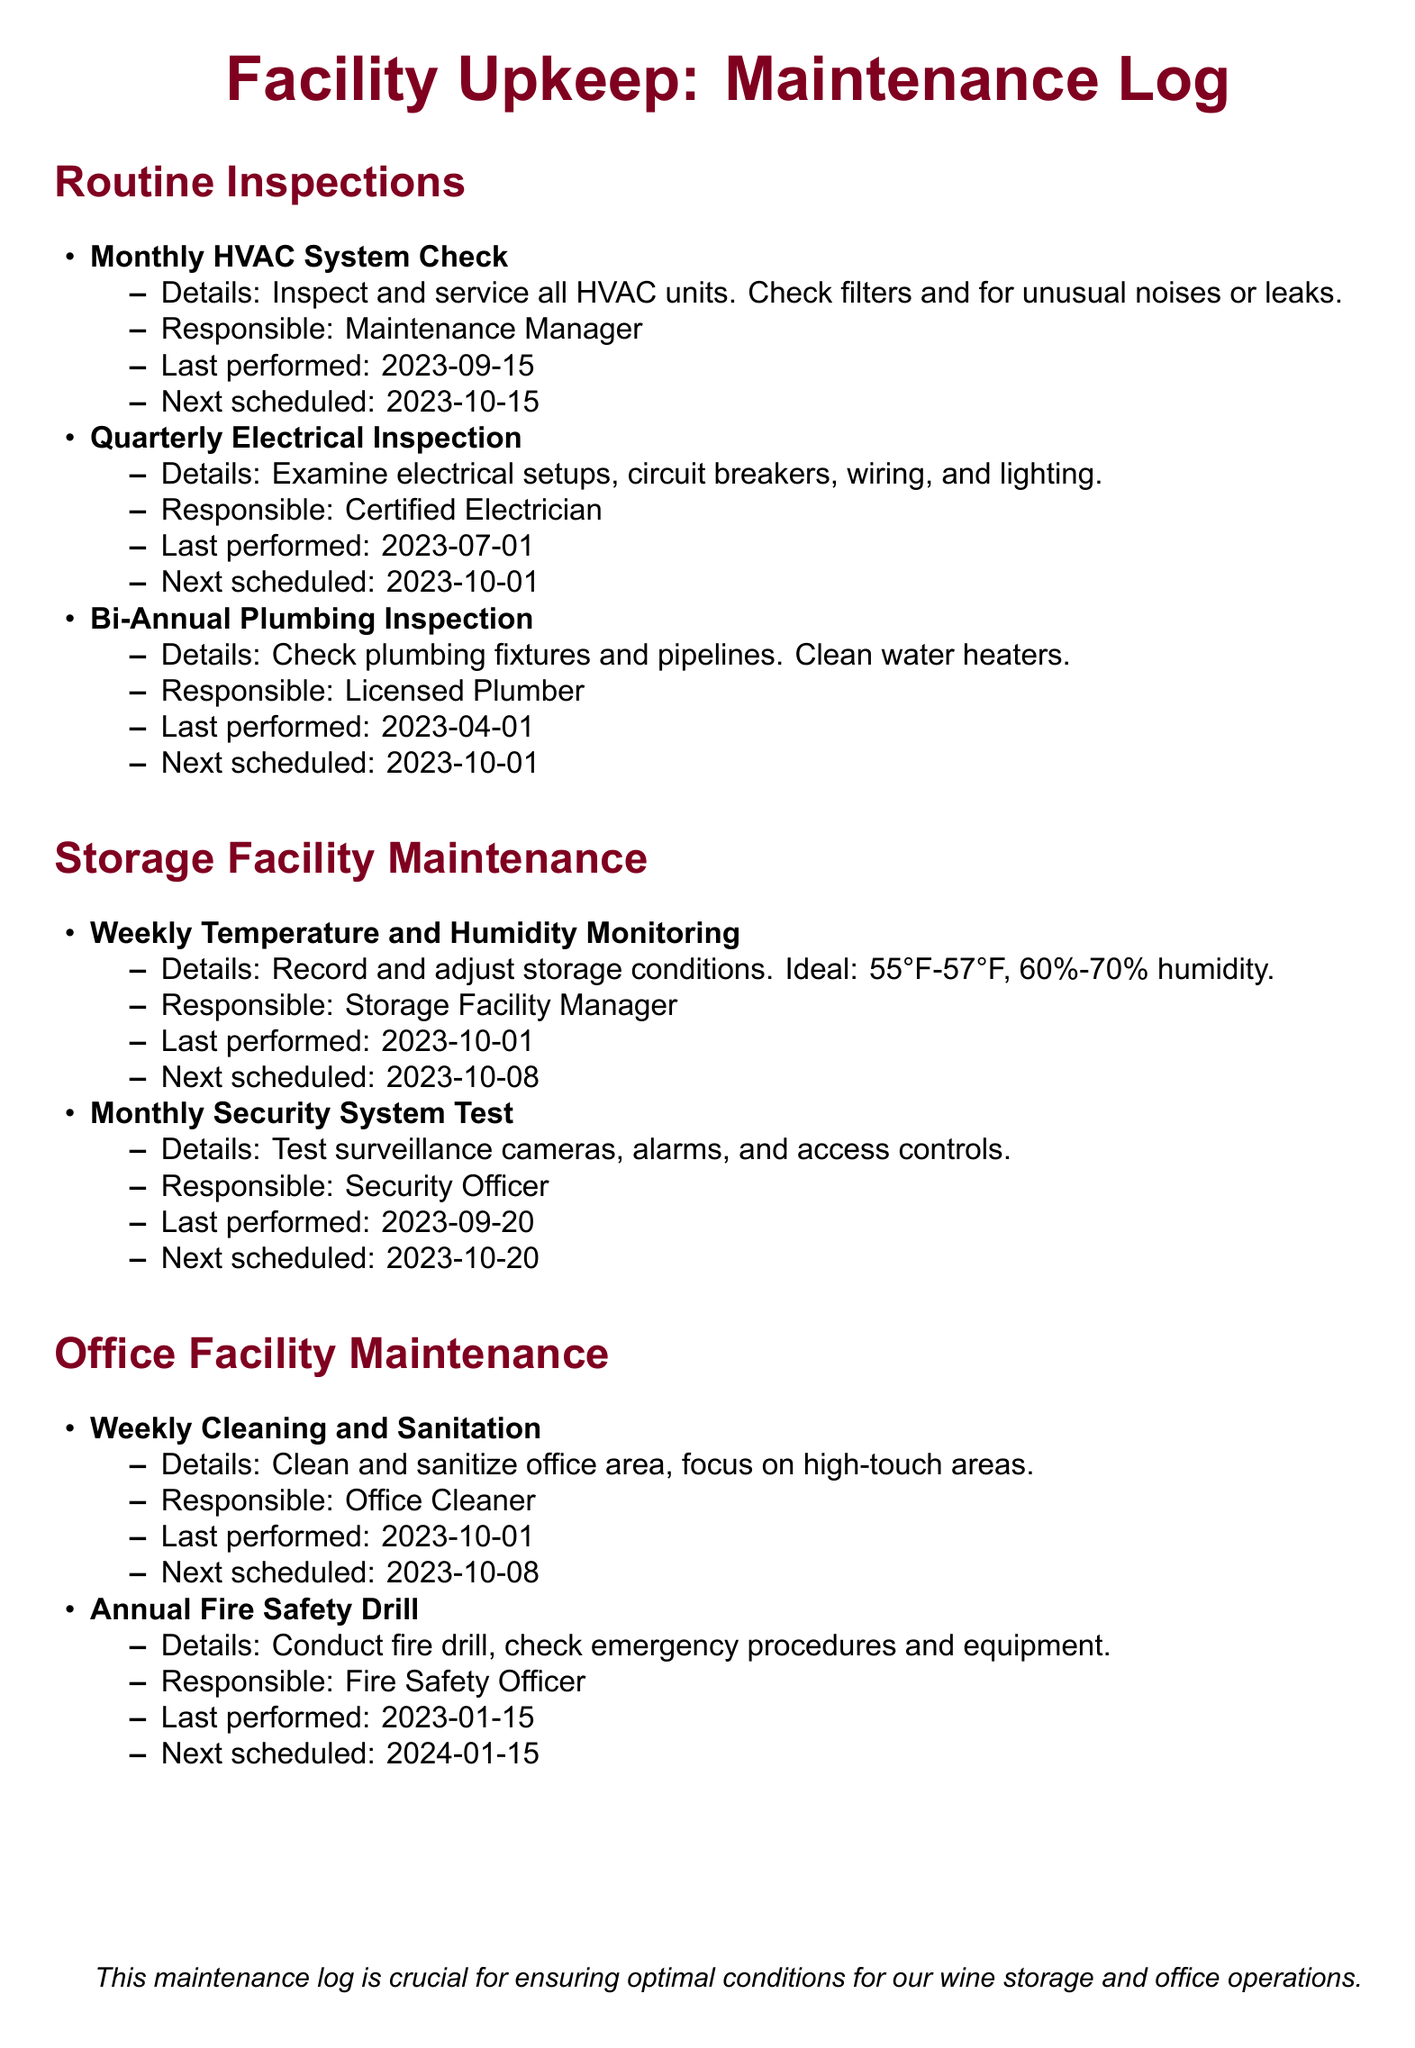What is the date of the last monthly HVAC system check? The last monthly HVAC system check was performed on September 15, 2023.
Answer: 2023-09-15 Who is responsible for the quarterly electrical inspection? The quarterly electrical inspection is the responsibility of the Certified Electrician.
Answer: Certified Electrician When is the next bi-annual plumbing inspection scheduled? The next bi-annual plumbing inspection is scheduled for October 1, 2023.
Answer: 2023-10-01 What humidity range is ideal for storage conditions? The ideal humidity range for storage conditions is 60%-70%.
Answer: 60%-70% How often is the temperature and humidity monitoring conducted? Temperature and humidity monitoring is conducted weekly.
Answer: Weekly What type of officer conducts the annual fire safety drill? The annual fire safety drill is conducted by the Fire Safety Officer.
Answer: Fire Safety Officer When was the last monthly security system test performed? The last monthly security system test was performed on September 20, 2023.
Answer: 2023-09-20 How frequently is HVAC system maintenance performed? HVAC system maintenance is performed monthly.
Answer: Monthly 